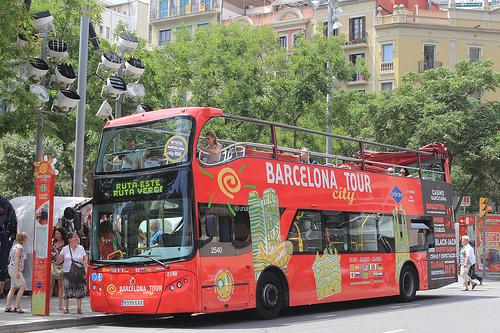Describe the image as though talking to a friend about something interesting you saw. Dude, you should've seen this extremely cool red double-decker bus with pictures, designs, and passengers on both levels, driving downtown! In a few words, tell me about the most eye-catching feature and the context it is in. There's a red double-decker bus filled with passengers, with interesting designs and pictures, driving on a street. List five key elements present in the image that contribute to its overall description. Red double-decker bus, passengers, street, sun design, buildings Provide a poetic description of the primary object and its surroundings in the image. A vessel of red and black, two-level bus scurries on the path, with faces peering from within, amid the city's sunlit wrath. Mention the most prominent object along with the supporting objects that bring out the scene in the picture. A busy red double-decker tour bus is on the street, with passengers aboard, people and buildings nearby, and a sun graphic design. Mention the primary mode of transportation in the image along with its distinct features. A double-decker bus with sun and flag designs, green letters, passengers on both levels, and a woman sitting on the upper level. In one sentence, summarize the overall scenario in the image. A lively city scene unfolds as a red double-decker bus adorned with designs and pictures cruises through the street filled with passengers. Write a short and crisp headline that captures the essence of the image. Vibrant Double-Decker Bus Carries Passengers through Bustling City Scene Briefly mention the core object and its activity in the image, along with any associated elements. A double-decker tour bus is driving on the street, with passengers enjoying the ride, while surrounded by people and buildings. Tell me about the primary vehicle in the picture and what is unique about it. There's a red double-decker bus on the street with sun and flag designs on its surface, and a woman is sitting on the upper level. 